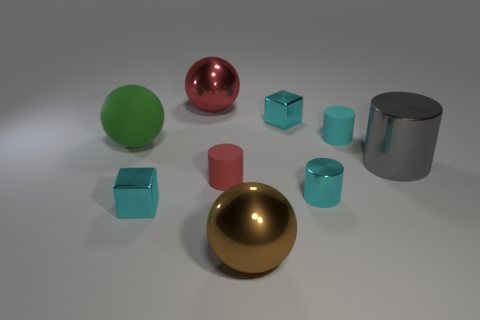Subtract all tiny metallic cylinders. How many cylinders are left? 3 Subtract all green spheres. How many spheres are left? 2 Subtract all cubes. How many objects are left? 7 Add 1 cyan matte balls. How many objects exist? 10 Subtract all brown balls. How many cyan cylinders are left? 2 Subtract all small red matte objects. Subtract all blocks. How many objects are left? 6 Add 5 red rubber cylinders. How many red rubber cylinders are left? 6 Add 8 big brown things. How many big brown things exist? 9 Subtract 0 blue cylinders. How many objects are left? 9 Subtract 1 cylinders. How many cylinders are left? 3 